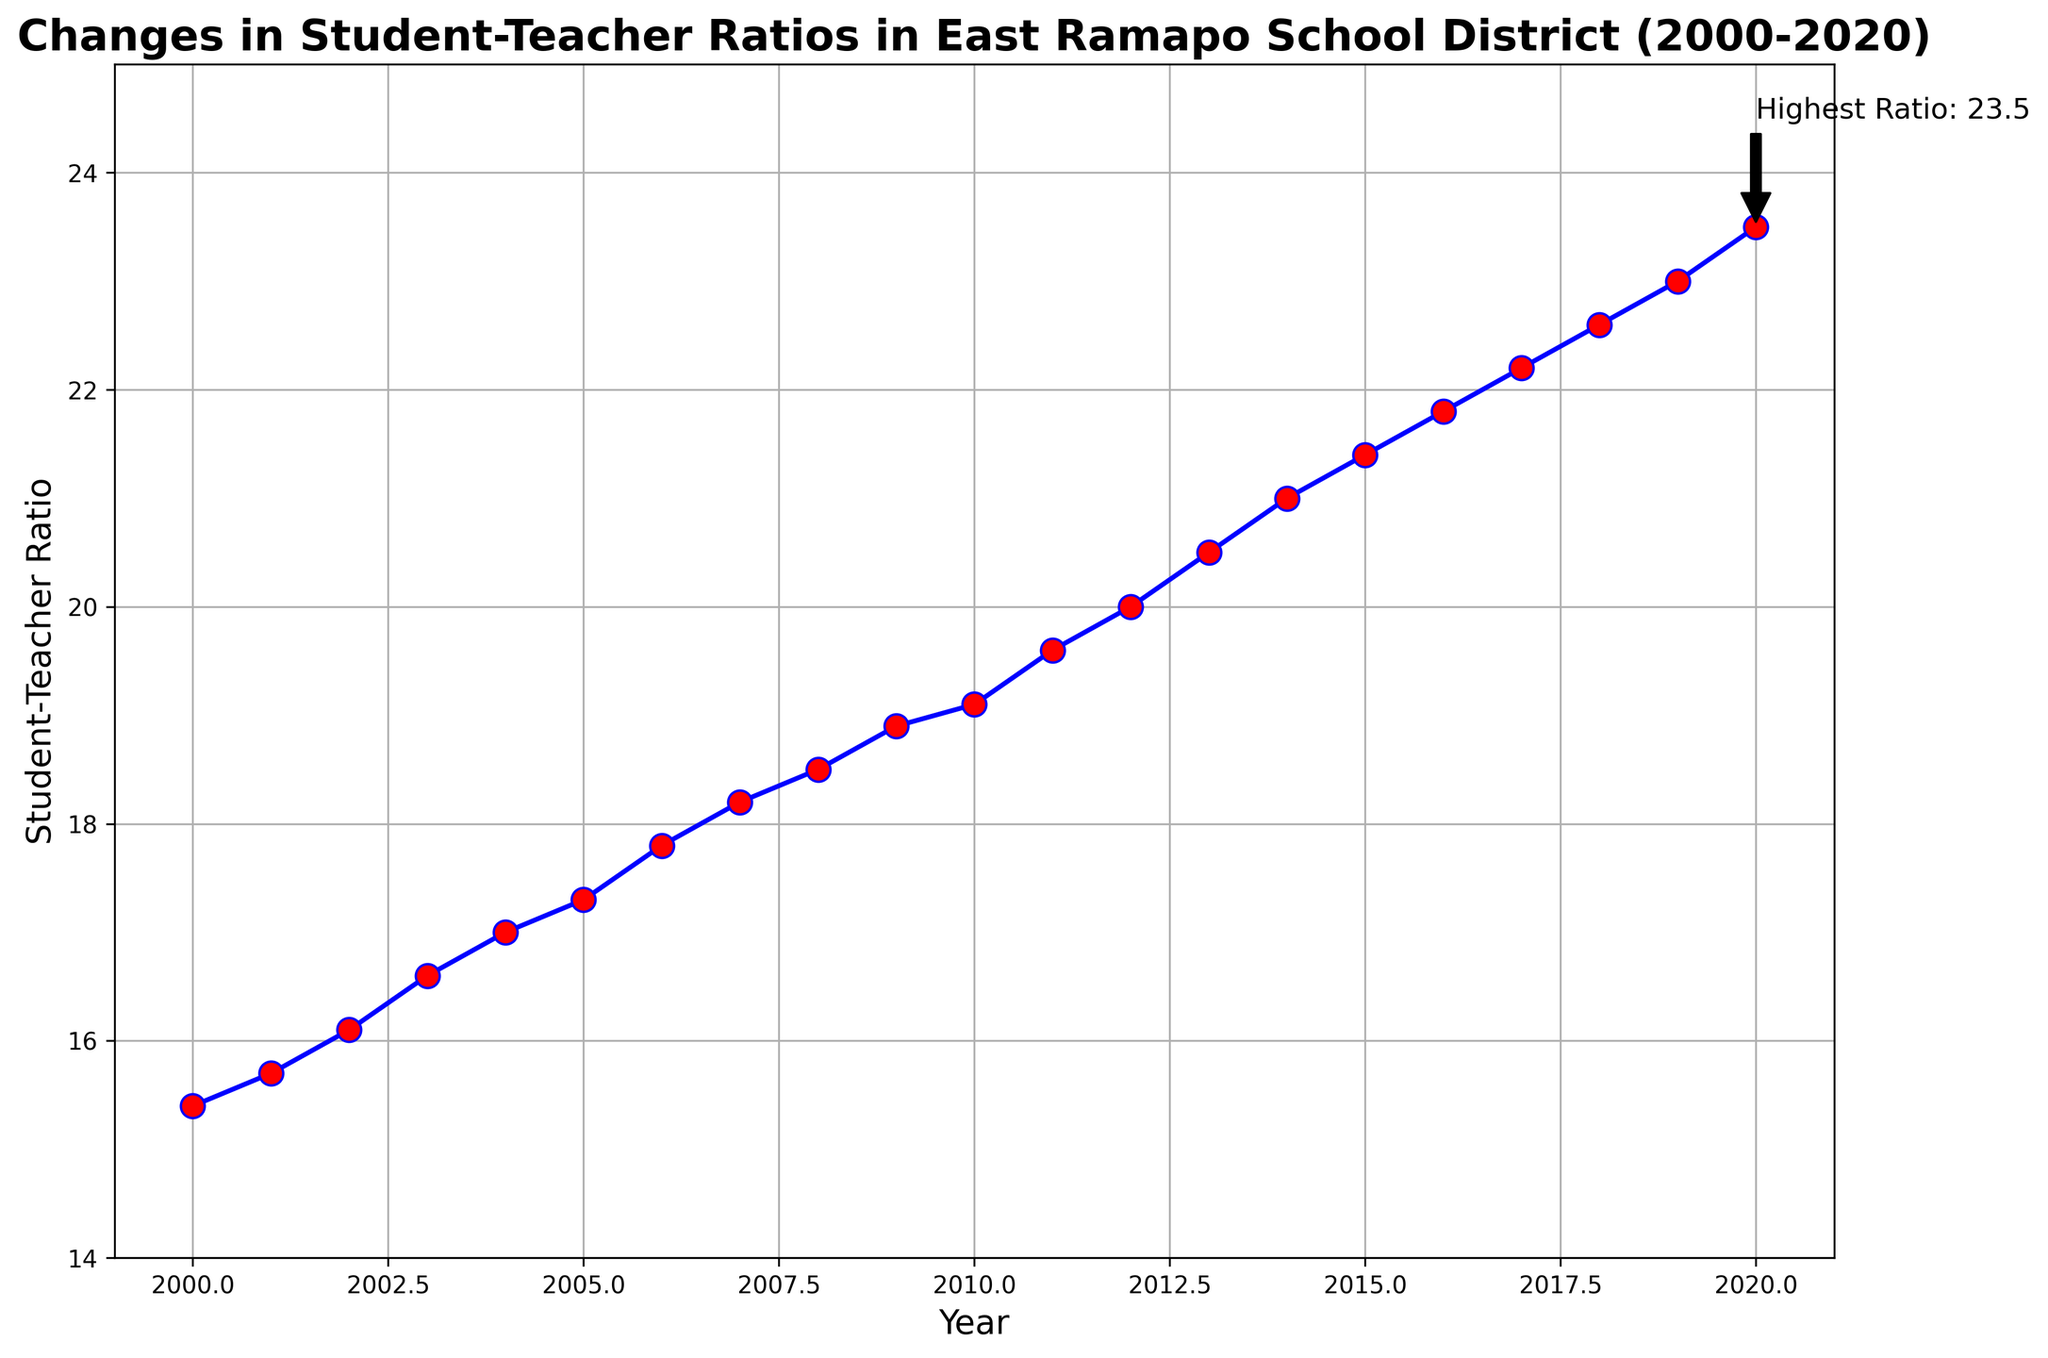What year had the highest student-teacher ratio? The annotation on the plot indicates the highest ratio and the year it occurred, which is clearly marked.
Answer: 2020 What was the student-teacher ratio in 2012? Look at the plotted points on the line chart and find the value for the year 2012.
Answer: 20.0 How much did the student-teacher ratio increase from 2000 to 2020? Subtract the student-teacher ratio in 2000 from the ratio in 2020. The difference is 23.5 - 15.4.
Answer: 8.1 Between which consecutive years did the student-teacher ratio increase the most? Compare the annual increases by subtracting each year's ratio from the previous year's ratio and find the maximum difference. The biggest jump is between 2008 and 2009 (18.9 - 18.5 = 0.4).
Answer: 2008 to 2009 By how much did the student-teacher ratio change on average per year over the 20-year period? Calculate the total change in the student-teacher ratio (23.5 - 15.4 = 8.1) and divide by the number of years (2020 - 2000 = 20).
Answer: 0.405 Which year had a student-teacher ratio closest to the value of 21.0? Identify the point labeled or closest to 21.0. Based on the plot, the year 2014 matches exactly.
Answer: 2014 Was there any year where the student-teacher ratio remained the same as the previous year? Examine the plot for any horizontal lines or points that do not ascend from one year to the next. There is no year where the ratio remains the same.
Answer: No How does the student-teacher ratio in 2005 compare to 2015? Refer to the plotted points or values for 2005 and 2015: 2005 has 17.3 and 2015 has 21.4. Therefore, 2015 has a higher ratio than 2005.
Answer: 2015 is higher What can be inferred about the trend in student-teacher ratios in East Ramapo School District from 2000 to 2020? The plot consistently shows an upward trend over the years, indicating that the student-teacher ratio has increased steadily from 2000 to 2020.
Answer: Increasing trend 